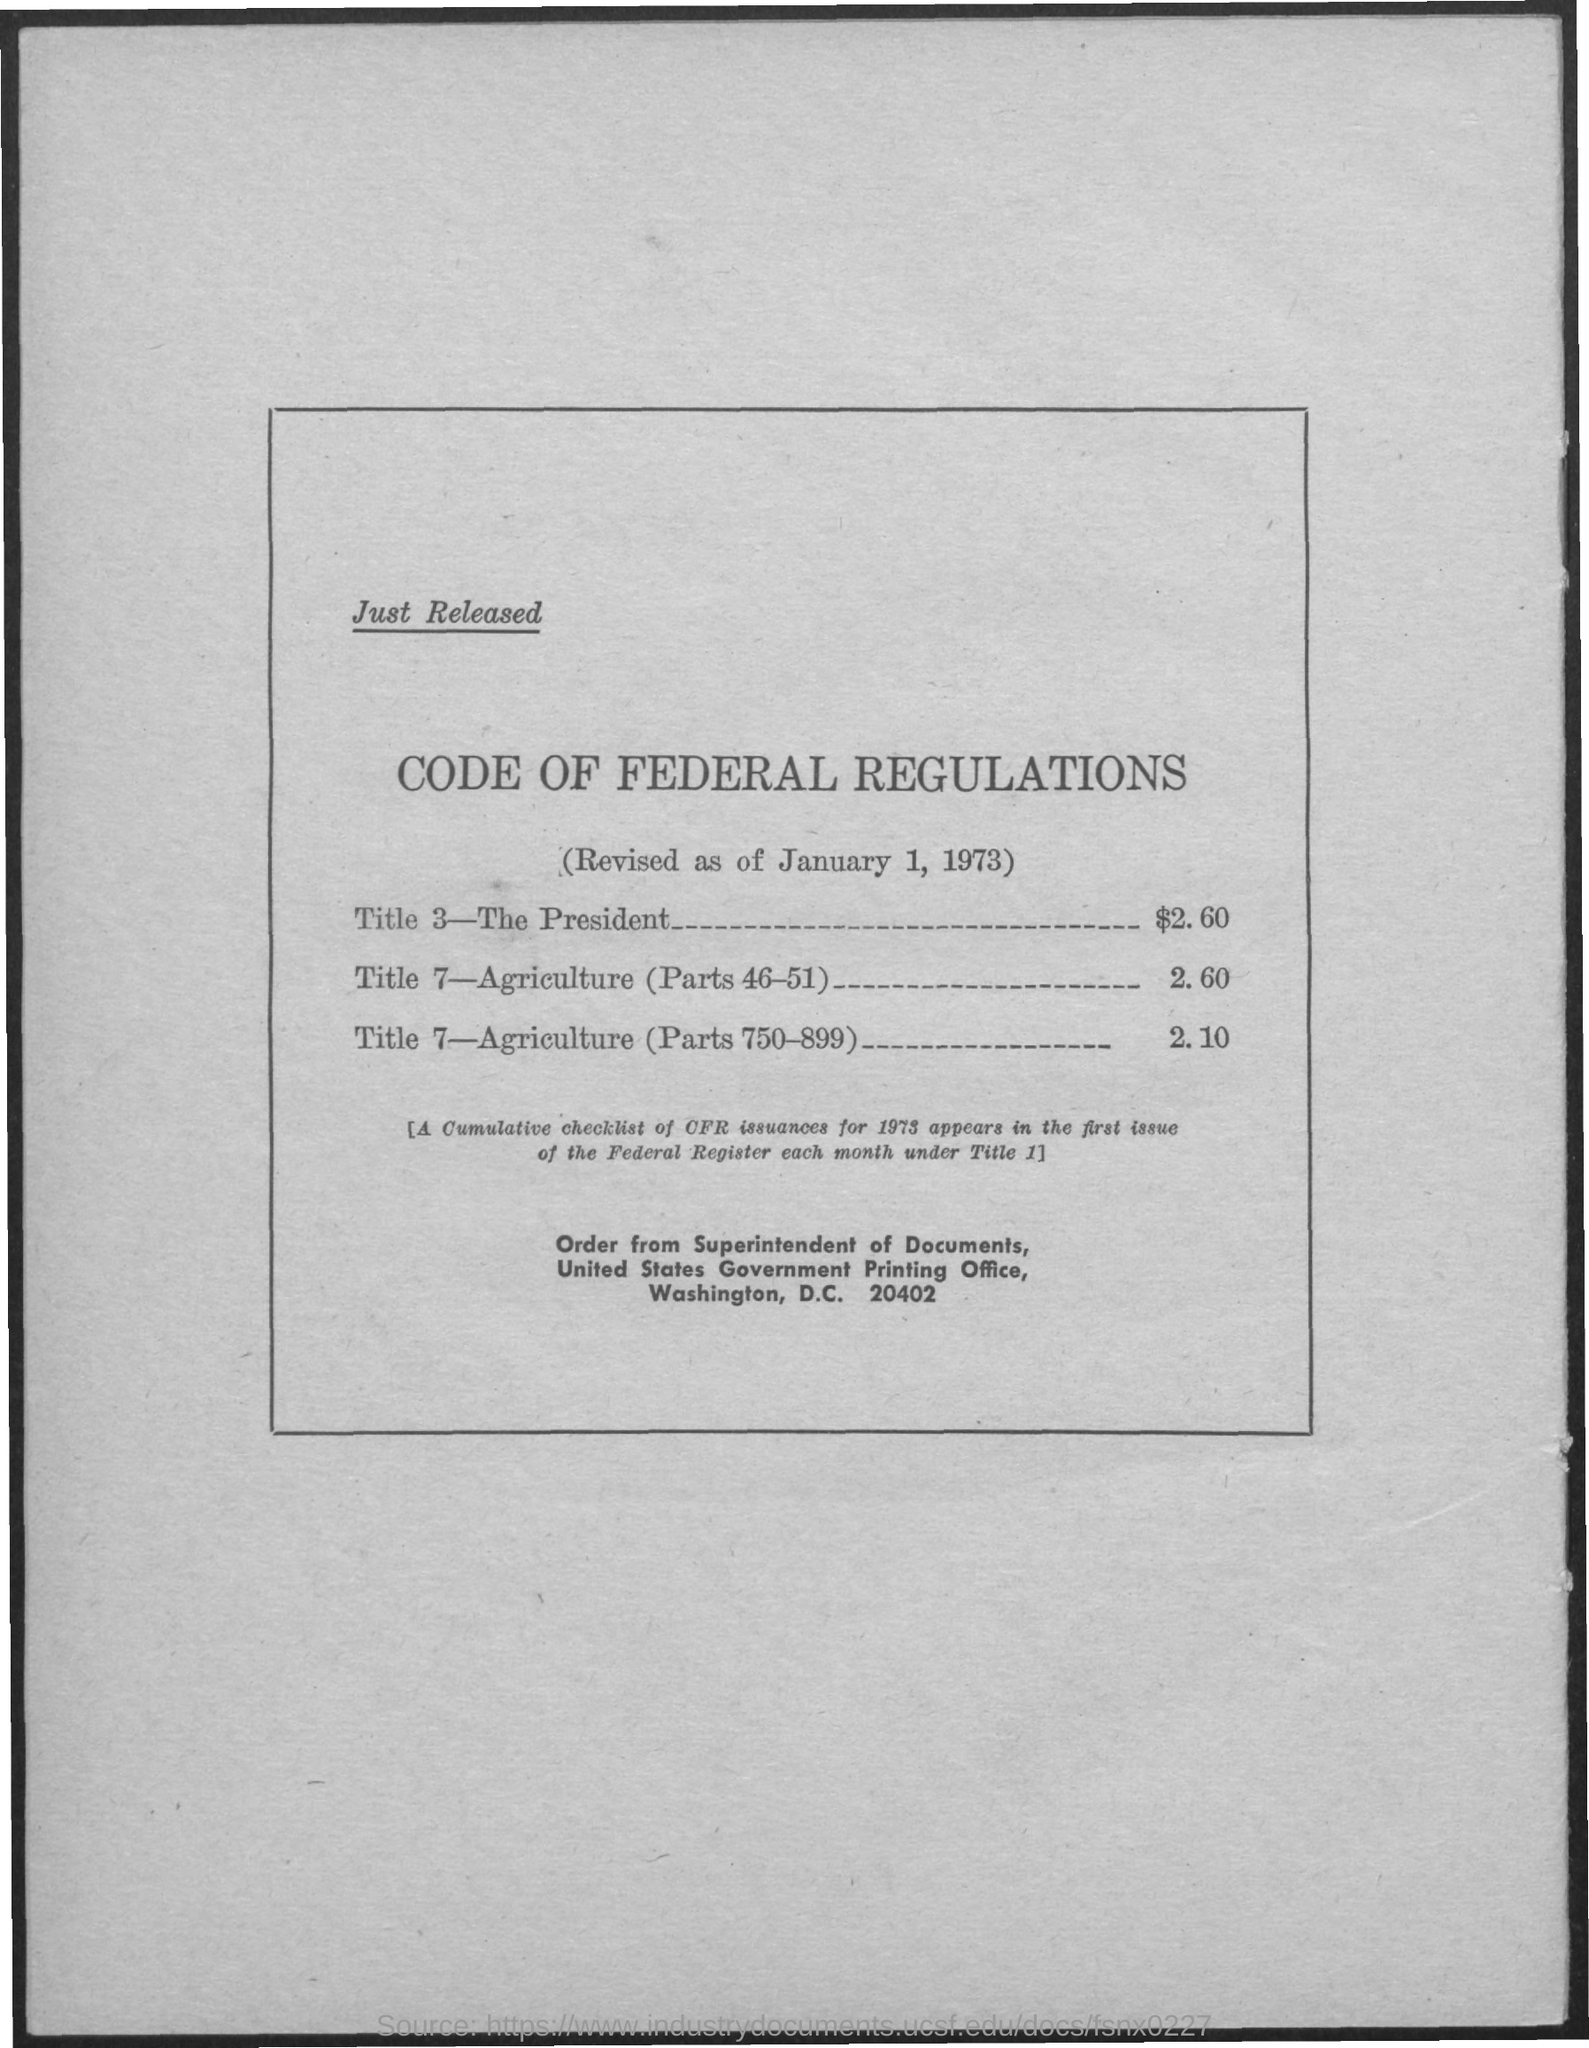What is the Title of the document?
Provide a short and direct response. Code of federal regulations. What is the cost of Title 3-The President?
Offer a terse response. $2.60. What is the cost of Title 7-Agriculture (Parts 46-51)?
Provide a succinct answer. 2.60. What is the cost of Title 7-Agriculture (Parts 750-899)?
Make the answer very short. 2.10. What is the date on the document?
Your response must be concise. January 1, 1973. Who to order from?
Keep it short and to the point. Superintendent of Documents. 